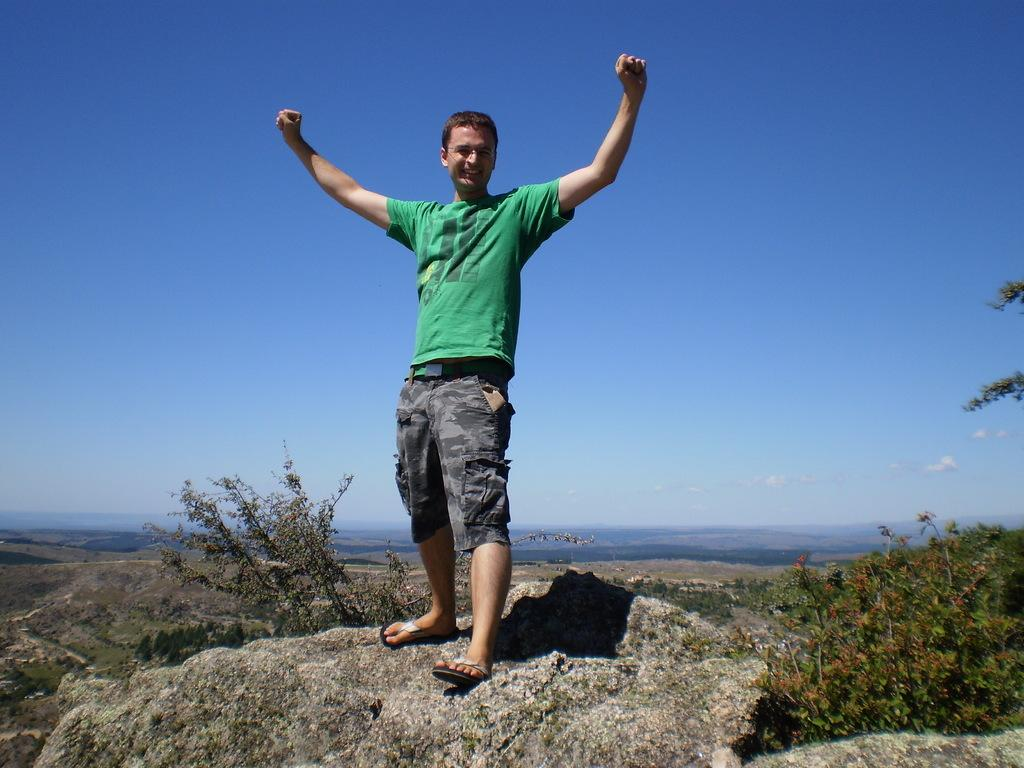Who is present in the image? There is a man in the picture. What is the man doing in the image? The man is standing in the image. What is the man's facial expression in the image? The man is smiling in the image. What is located at the bottom of the picture? There is a rock at the bottom of the picture. What type of vegetation can be seen in the image? Plants are visible in the picture. What is visible at the top of the picture? The sky is visible at the top of the picture. What type of van can be seen in the background of the image? There is no van present in the image. What hope does the man have for the future, as depicted in the image? The image does not provide any information about the man's hopes for the future. 